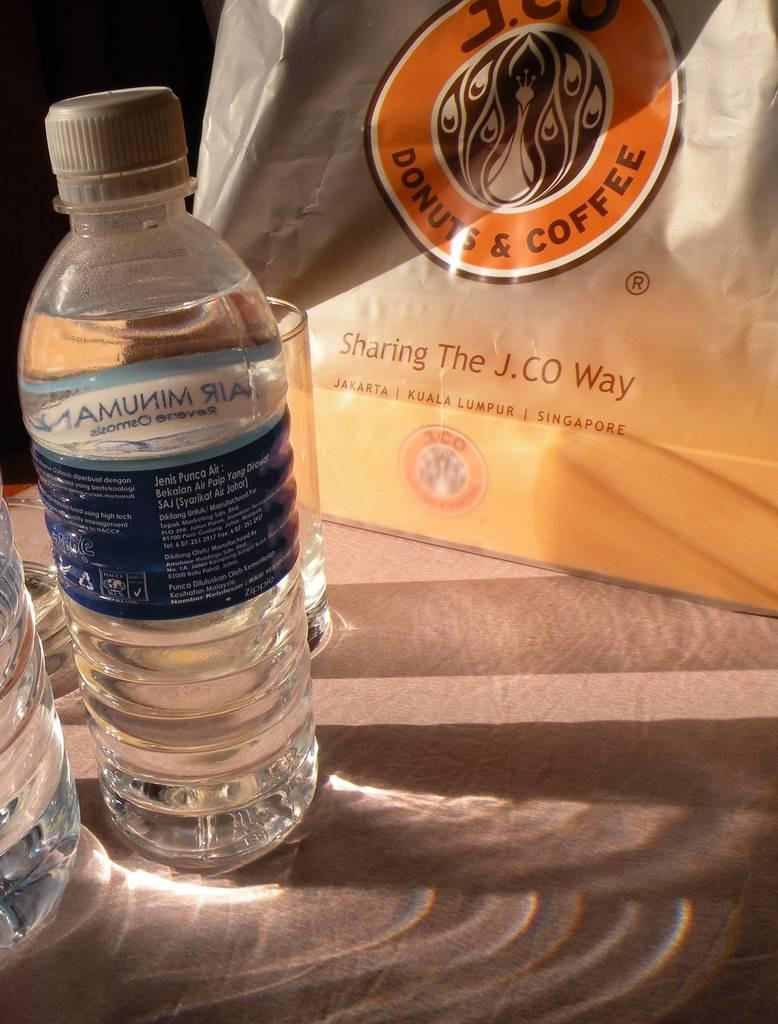<image>
Describe the image concisely. A bottle of water is next to a bag that says Donuts and Coffee. 